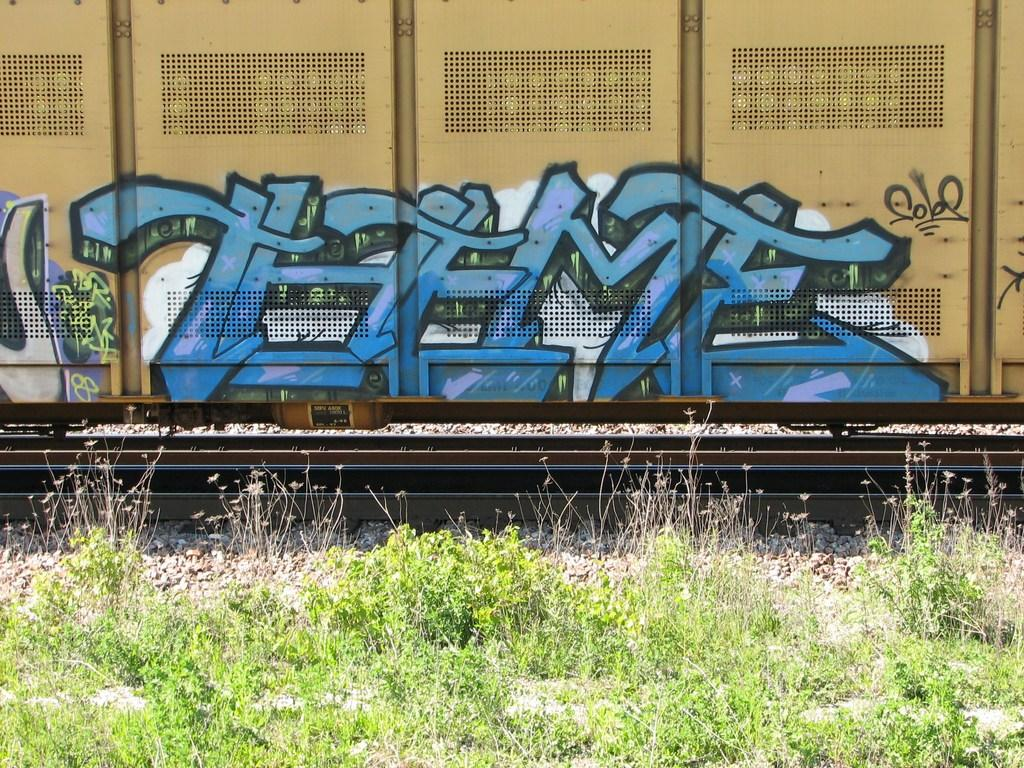<image>
Describe the image concisely. the word theme that is on a train 